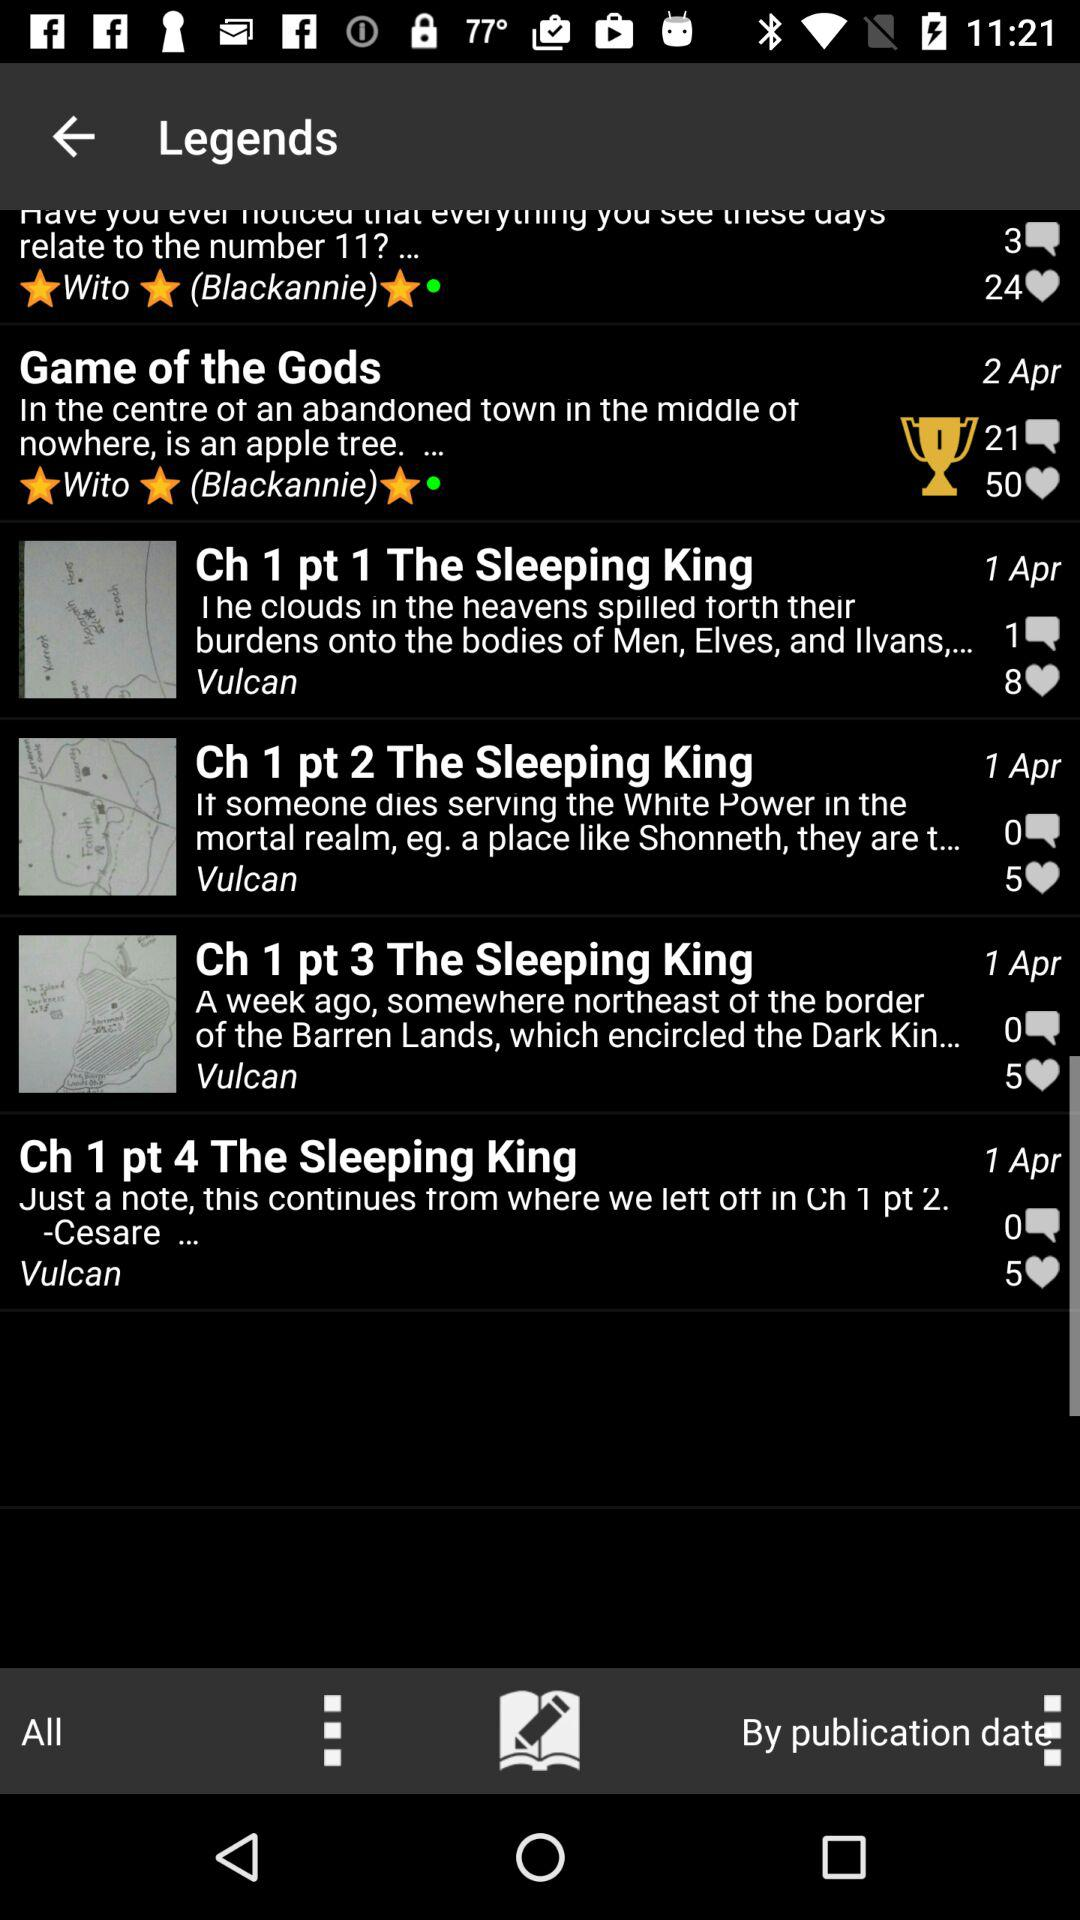How many chapters of The Sleeping King are there?
Answer the question using a single word or phrase. 4 